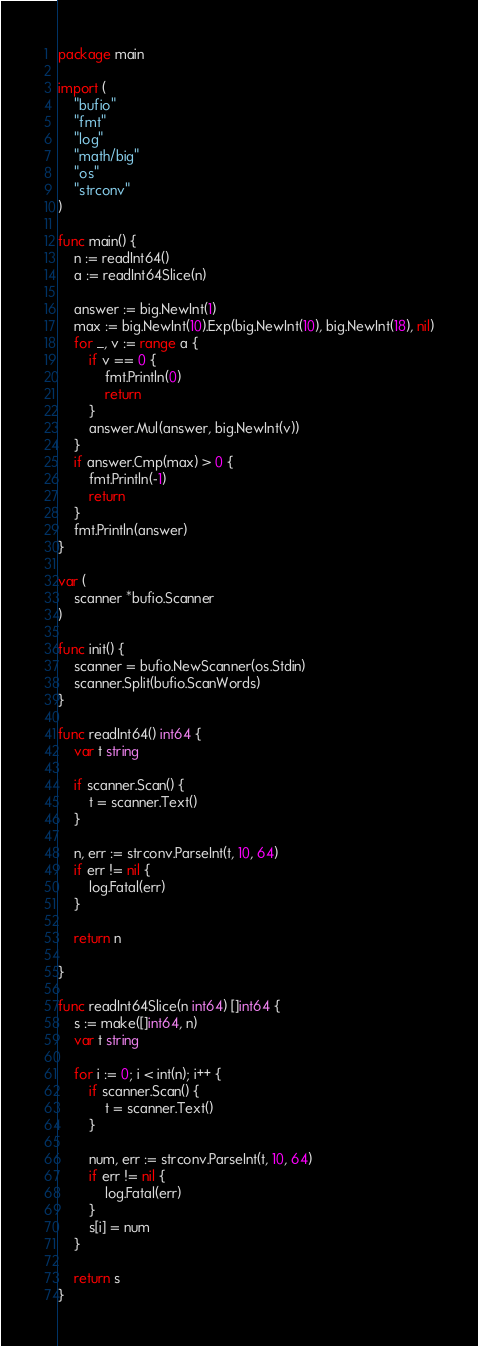<code> <loc_0><loc_0><loc_500><loc_500><_Go_>package main

import (
	"bufio"
	"fmt"
	"log"
	"math/big"
	"os"
	"strconv"
)

func main() {
	n := readInt64()
	a := readInt64Slice(n)

	answer := big.NewInt(1)
	max := big.NewInt(10).Exp(big.NewInt(10), big.NewInt(18), nil)
	for _, v := range a {
		if v == 0 {
			fmt.Println(0)
			return
		}
		answer.Mul(answer, big.NewInt(v))
	}
	if answer.Cmp(max) > 0 {
		fmt.Println(-1)
		return
	}
	fmt.Println(answer)
}

var (
	scanner *bufio.Scanner
)

func init() {
	scanner = bufio.NewScanner(os.Stdin)
	scanner.Split(bufio.ScanWords)
}

func readInt64() int64 {
	var t string

	if scanner.Scan() {
		t = scanner.Text()
	}

	n, err := strconv.ParseInt(t, 10, 64)
	if err != nil {
		log.Fatal(err)
	}

	return n

}

func readInt64Slice(n int64) []int64 {
	s := make([]int64, n)
	var t string

	for i := 0; i < int(n); i++ {
		if scanner.Scan() {
			t = scanner.Text()
		}

		num, err := strconv.ParseInt(t, 10, 64)
		if err != nil {
			log.Fatal(err)
		}
		s[i] = num
	}

	return s
}
</code> 